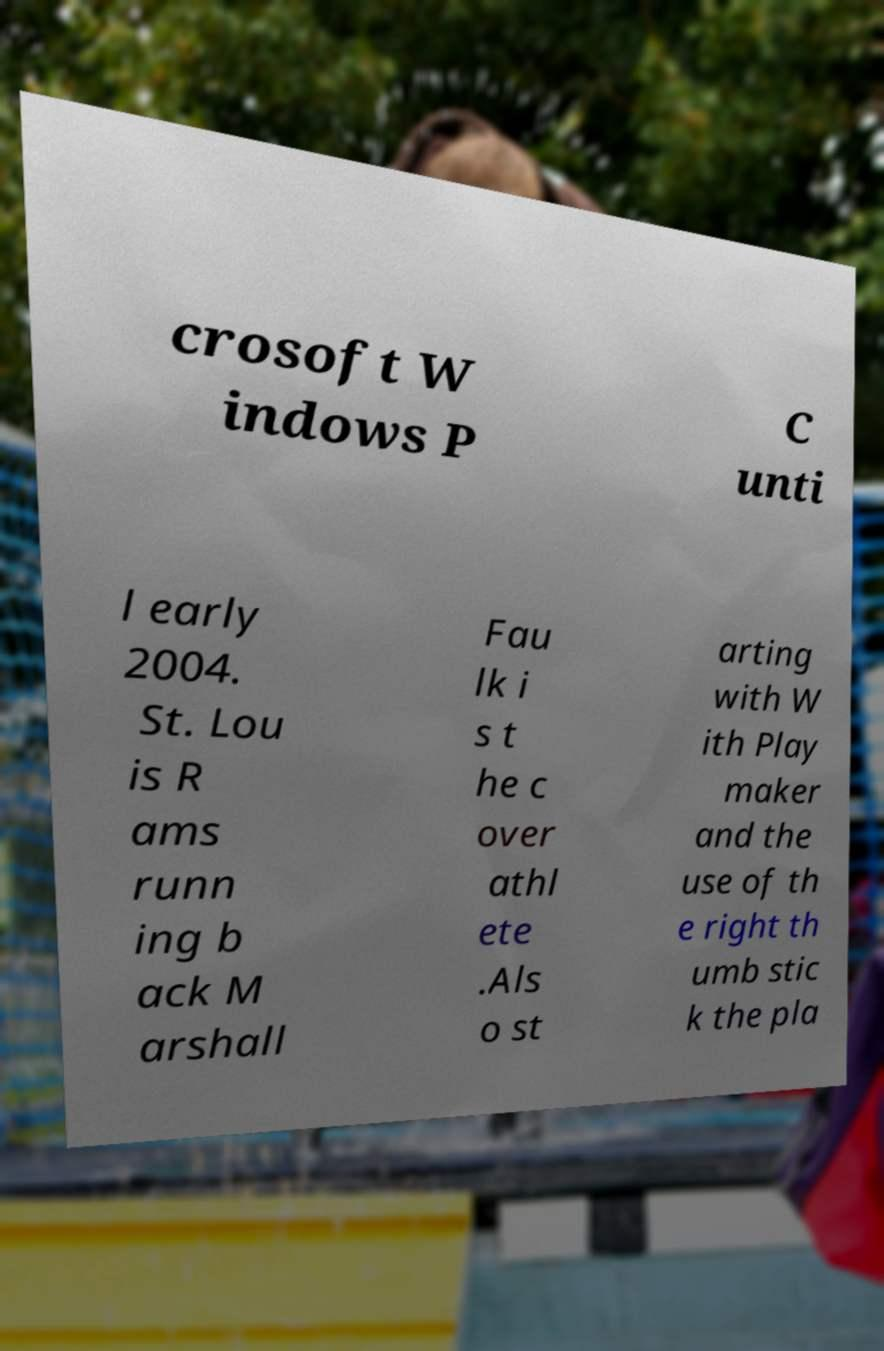I need the written content from this picture converted into text. Can you do that? crosoft W indows P C unti l early 2004. St. Lou is R ams runn ing b ack M arshall Fau lk i s t he c over athl ete .Als o st arting with W ith Play maker and the use of th e right th umb stic k the pla 